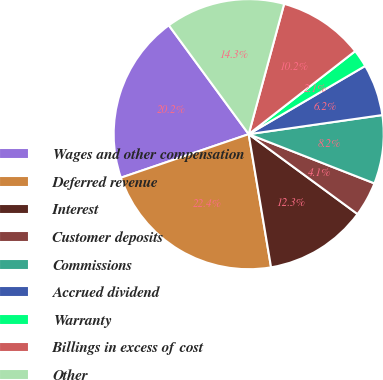<chart> <loc_0><loc_0><loc_500><loc_500><pie_chart><fcel>Wages and other compensation<fcel>Deferred revenue<fcel>Interest<fcel>Customer deposits<fcel>Commissions<fcel>Accrued dividend<fcel>Warranty<fcel>Billings in excess of cost<fcel>Other<nl><fcel>20.15%<fcel>22.42%<fcel>12.27%<fcel>4.14%<fcel>8.2%<fcel>6.17%<fcel>2.11%<fcel>10.23%<fcel>14.3%<nl></chart> 